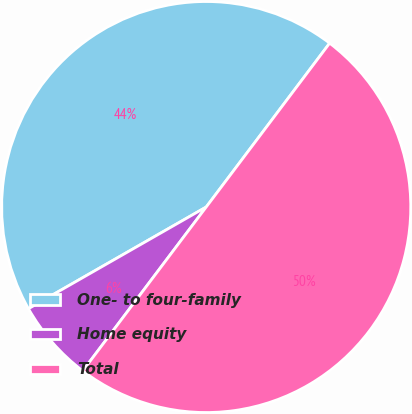<chart> <loc_0><loc_0><loc_500><loc_500><pie_chart><fcel>One- to four-family<fcel>Home equity<fcel>Total<nl><fcel>43.55%<fcel>6.45%<fcel>50.0%<nl></chart> 